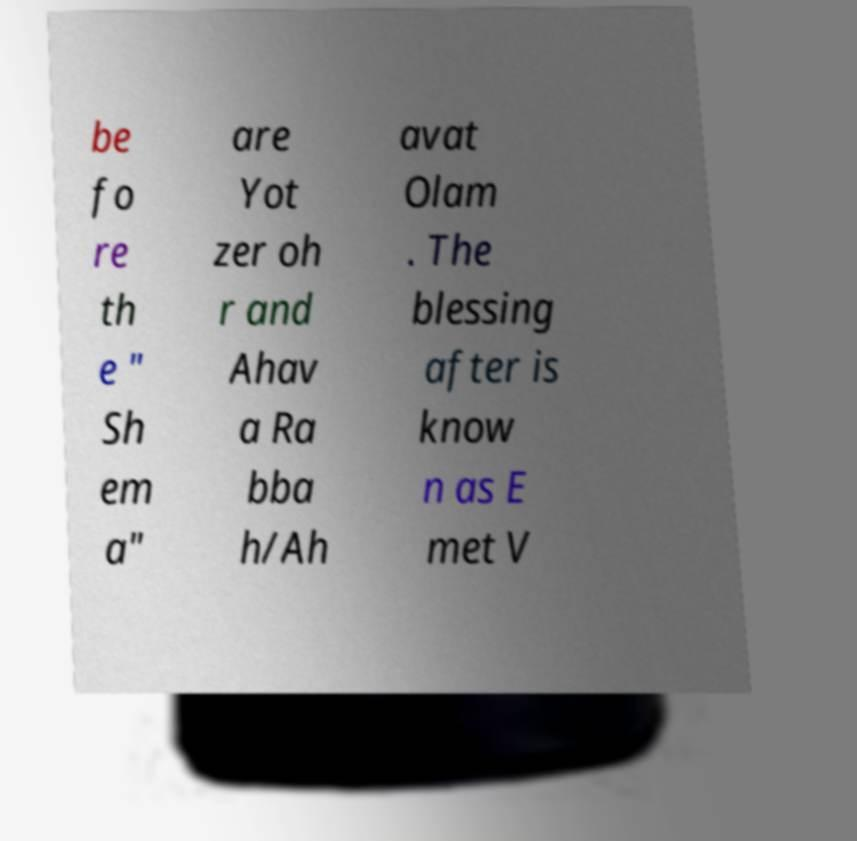Please identify and transcribe the text found in this image. be fo re th e " Sh em a" are Yot zer oh r and Ahav a Ra bba h/Ah avat Olam . The blessing after is know n as E met V 